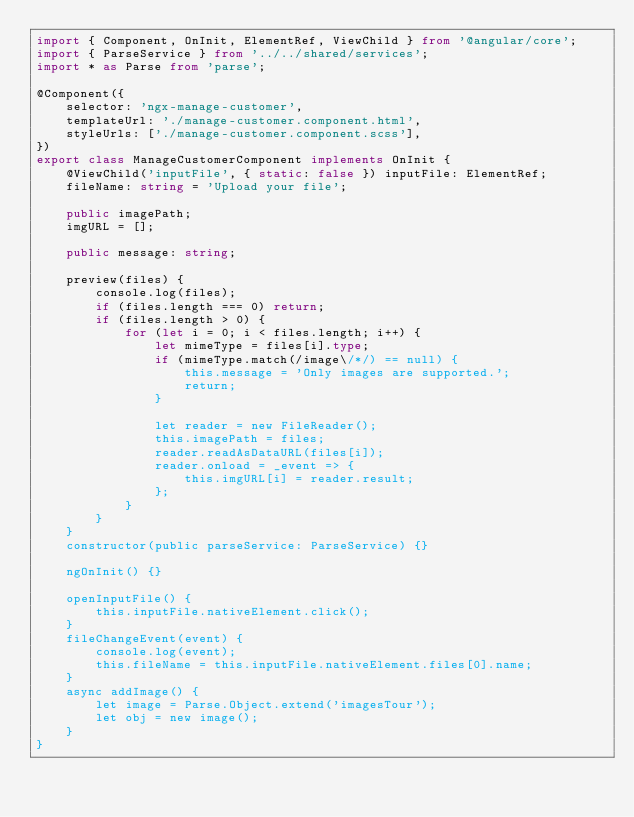Convert code to text. <code><loc_0><loc_0><loc_500><loc_500><_TypeScript_>import { Component, OnInit, ElementRef, ViewChild } from '@angular/core';
import { ParseService } from '../../shared/services';
import * as Parse from 'parse';

@Component({
    selector: 'ngx-manage-customer',
    templateUrl: './manage-customer.component.html',
    styleUrls: ['./manage-customer.component.scss'],
})
export class ManageCustomerComponent implements OnInit {
    @ViewChild('inputFile', { static: false }) inputFile: ElementRef;
    fileName: string = 'Upload your file';

    public imagePath;
    imgURL = [];

    public message: string;

    preview(files) {
        console.log(files);
        if (files.length === 0) return;
        if (files.length > 0) {
            for (let i = 0; i < files.length; i++) {
                let mimeType = files[i].type;
                if (mimeType.match(/image\/*/) == null) {
                    this.message = 'Only images are supported.';
                    return;
                }

                let reader = new FileReader();
                this.imagePath = files;
                reader.readAsDataURL(files[i]);
                reader.onload = _event => {
                    this.imgURL[i] = reader.result;
                };
            }
        }
    }
    constructor(public parseService: ParseService) {}

    ngOnInit() {}

    openInputFile() {
        this.inputFile.nativeElement.click();
    }
    fileChangeEvent(event) {
        console.log(event);
        this.fileName = this.inputFile.nativeElement.files[0].name;
    }
    async addImage() {
        let image = Parse.Object.extend('imagesTour');
        let obj = new image();
    }
}
</code> 